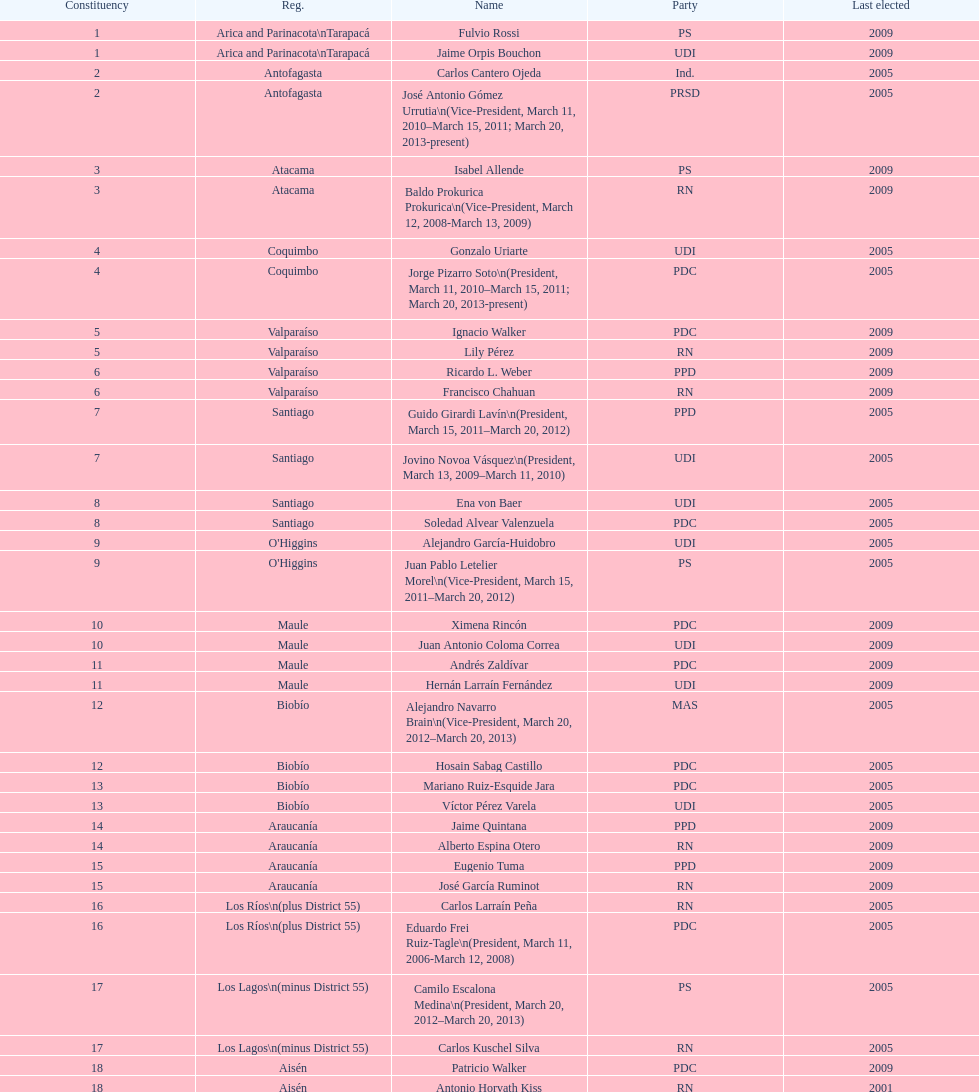Which region is listed below atacama? Coquimbo. 